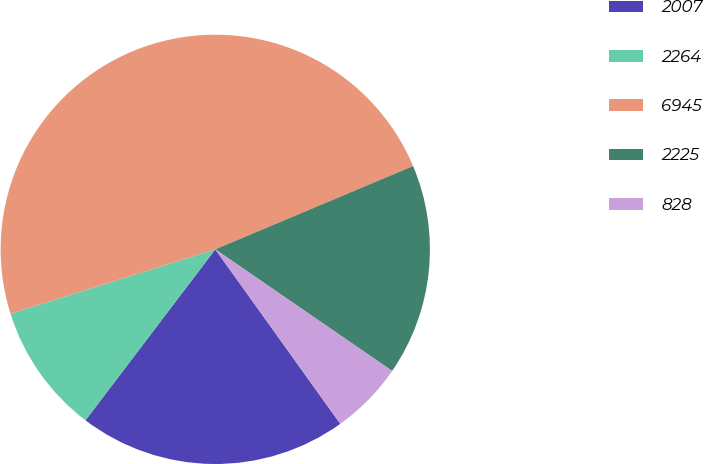<chart> <loc_0><loc_0><loc_500><loc_500><pie_chart><fcel>2007<fcel>2264<fcel>6945<fcel>2225<fcel>828<nl><fcel>20.23%<fcel>9.82%<fcel>48.51%<fcel>15.93%<fcel>5.52%<nl></chart> 